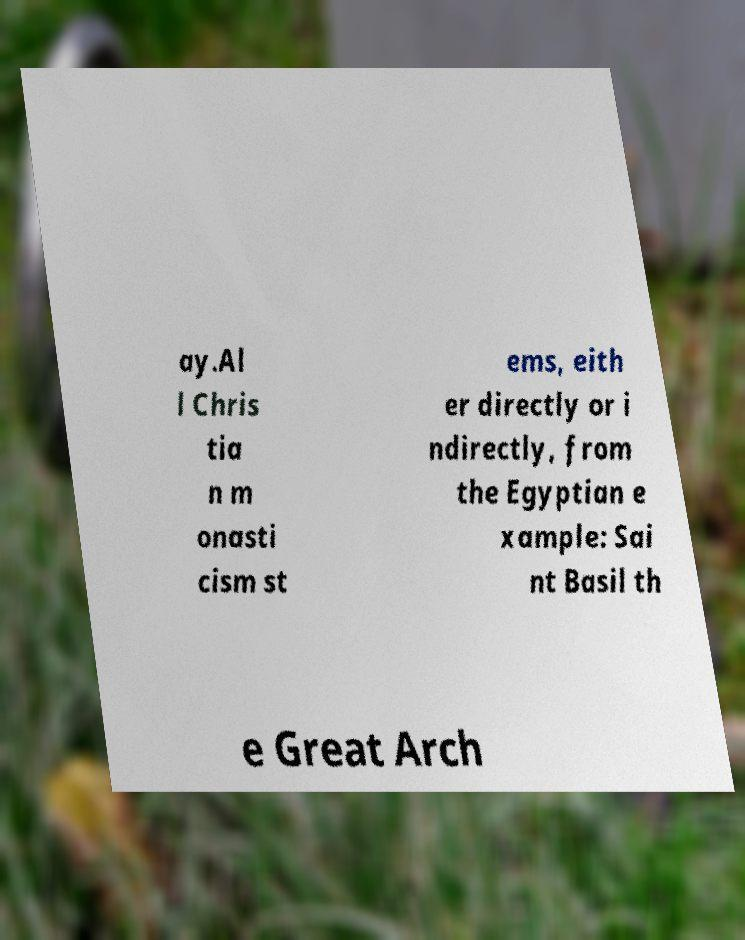Please identify and transcribe the text found in this image. ay.Al l Chris tia n m onasti cism st ems, eith er directly or i ndirectly, from the Egyptian e xample: Sai nt Basil th e Great Arch 